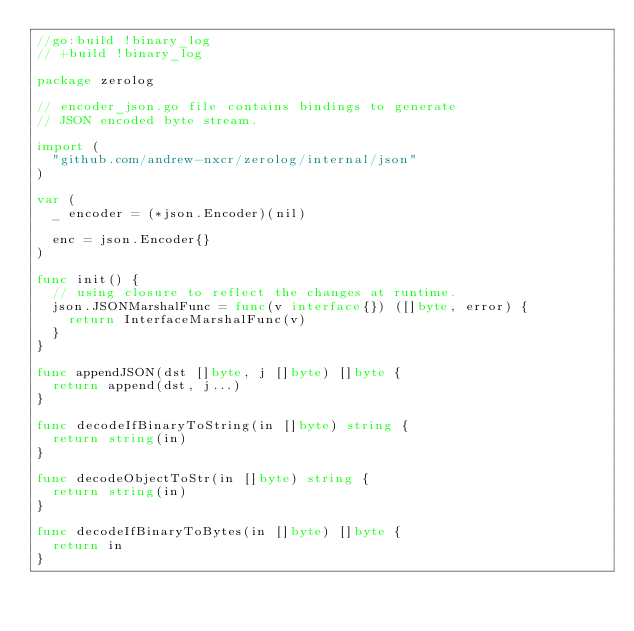<code> <loc_0><loc_0><loc_500><loc_500><_Go_>//go:build !binary_log
// +build !binary_log

package zerolog

// encoder_json.go file contains bindings to generate
// JSON encoded byte stream.

import (
	"github.com/andrew-nxcr/zerolog/internal/json"
)

var (
	_ encoder = (*json.Encoder)(nil)

	enc = json.Encoder{}
)

func init() {
	// using closure to reflect the changes at runtime.
	json.JSONMarshalFunc = func(v interface{}) ([]byte, error) {
		return InterfaceMarshalFunc(v)
	}
}

func appendJSON(dst []byte, j []byte) []byte {
	return append(dst, j...)
}

func decodeIfBinaryToString(in []byte) string {
	return string(in)
}

func decodeObjectToStr(in []byte) string {
	return string(in)
}

func decodeIfBinaryToBytes(in []byte) []byte {
	return in
}
</code> 